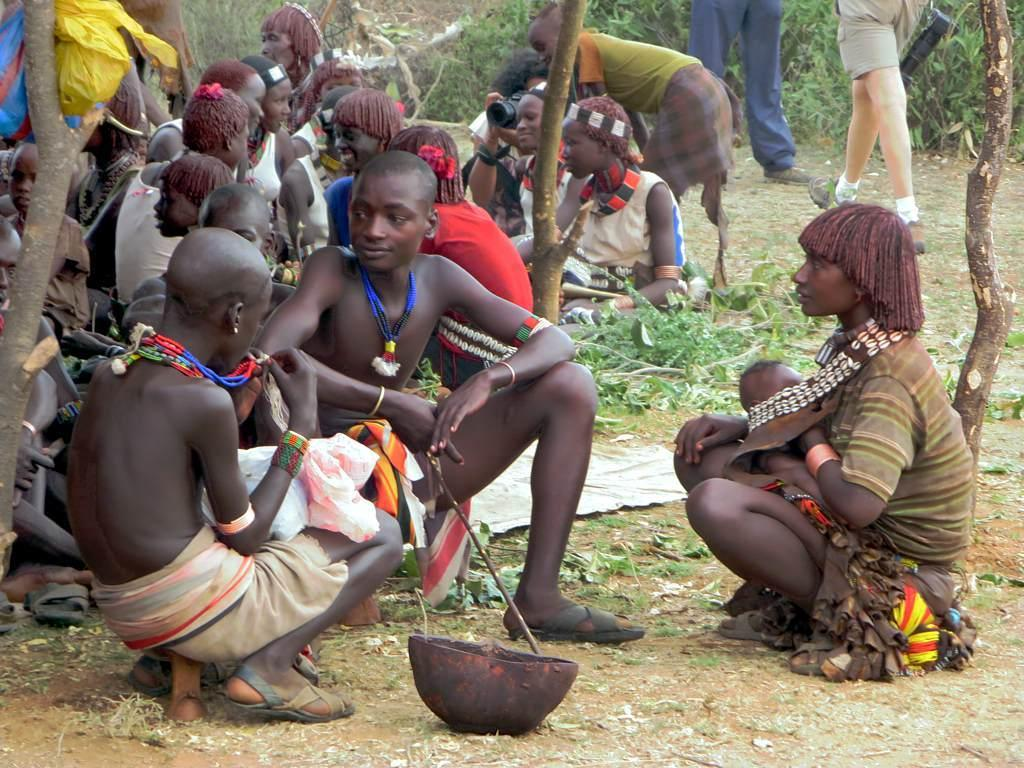What is the main subject of the image? The main subject of the image is a group of people. What object can be seen in the image besides the people? There is a bowl in the image. What can be seen in the background of the image? There are plants in the background of the image. What type of badge is the person wearing in the image? There is no badge visible on any person in the image. Can you tell me how many socks are present in the image? There is no mention of socks in the image, so it is impossible to determine their presence or quantity. 